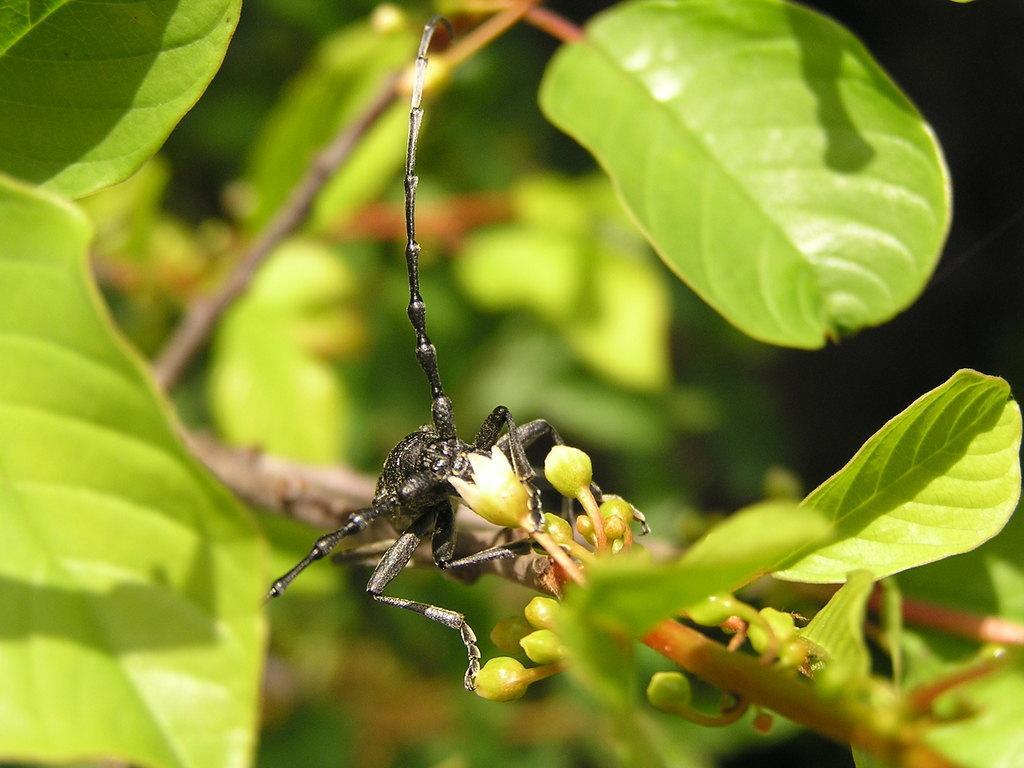Describe this image in one or two sentences. In this picture there is an insect in the center of the image, on a stem and there are leaves around the area of the image. 